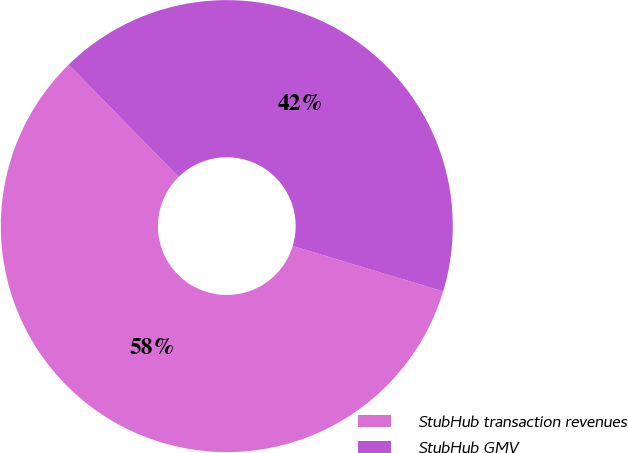<chart> <loc_0><loc_0><loc_500><loc_500><pie_chart><fcel>StubHub transaction revenues<fcel>StubHub GMV<nl><fcel>58.0%<fcel>42.0%<nl></chart> 